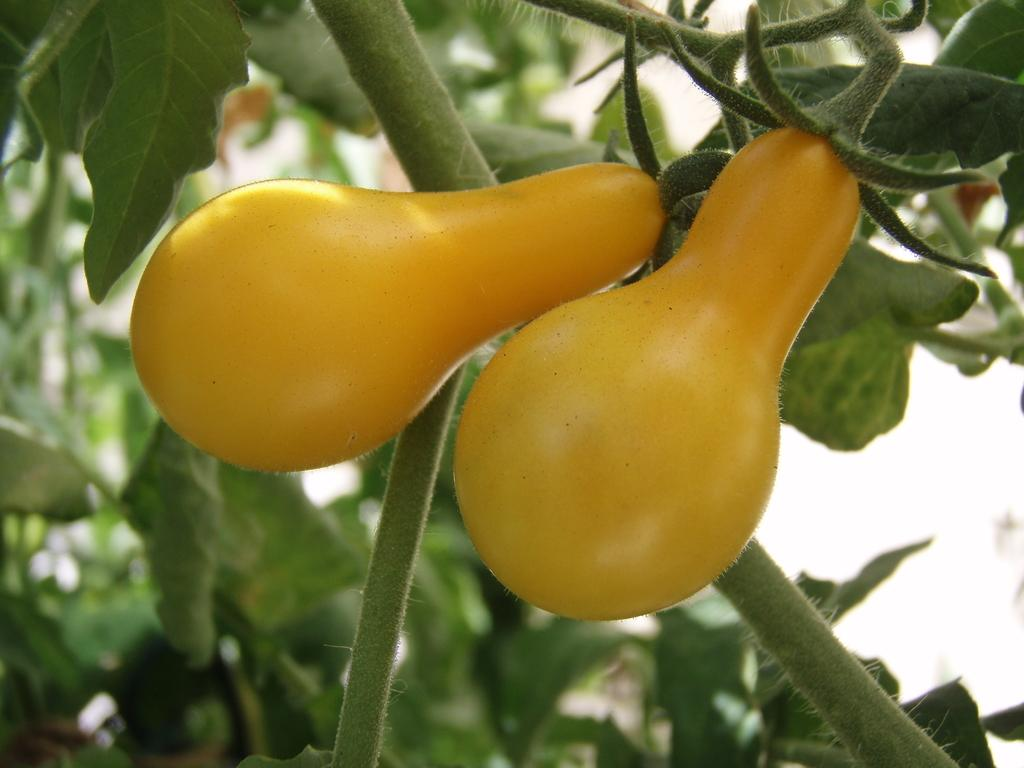What type of fruit can be seen on a branch in the image? There are pears on a branch in the image. What type of vegetation is present in the image? There are trees in the image. Can you see any goldfish swimming in the image? There are no goldfish present in the image. Is there any visible light source in the image? The image does not show any light source, as it appears to be a photograph taken outdoors during daylight. Are there any letters or words visible in the image? There are no letters or words visible in the image; it primarily features pears on a branch and trees. 